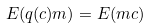Convert formula to latex. <formula><loc_0><loc_0><loc_500><loc_500>E ( q ( c ) m ) = E ( m c )</formula> 